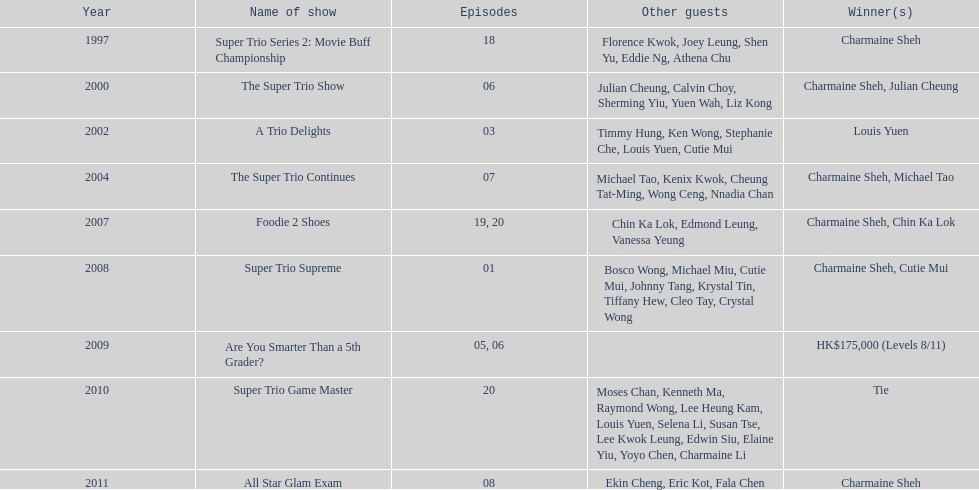How many times has charmaine sheh won on a variety show? 6. 